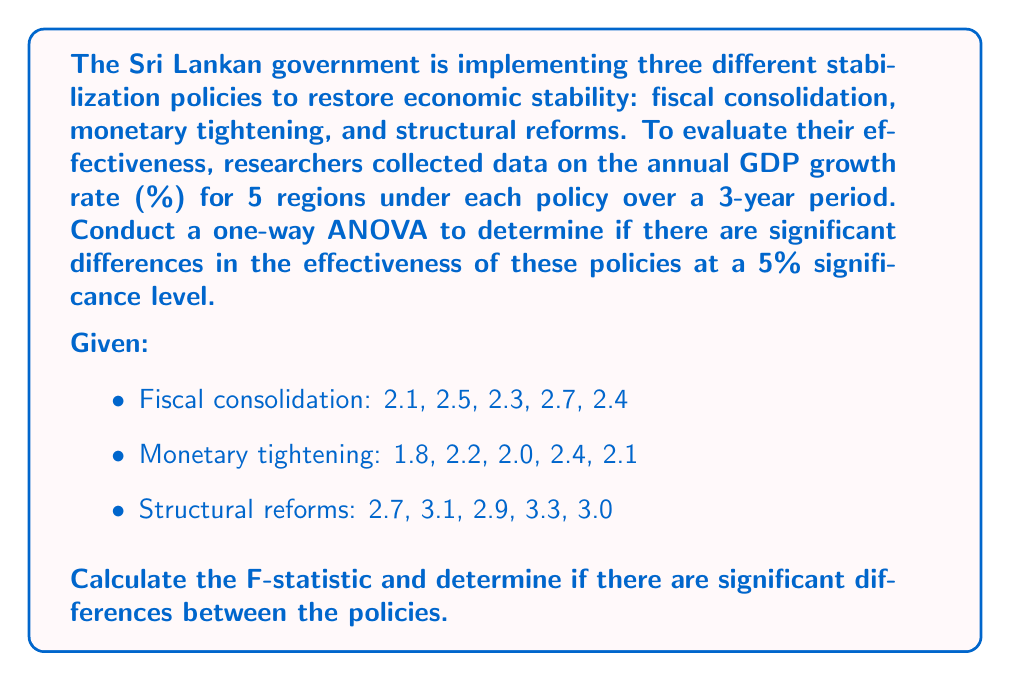Could you help me with this problem? To conduct a one-way ANOVA, we'll follow these steps:

1. Calculate the means for each group:
   Fiscal consolidation: $\bar{x}_1 = \frac{2.1 + 2.5 + 2.3 + 2.7 + 2.4}{5} = 2.4$
   Monetary tightening: $\bar{x}_2 = \frac{1.8 + 2.2 + 2.0 + 2.4 + 2.1}{5} = 2.1$
   Structural reforms: $\bar{x}_3 = \frac{2.7 + 3.1 + 2.9 + 3.3 + 3.0}{5} = 3.0$

2. Calculate the grand mean:
   $\bar{x} = \frac{2.4 + 2.1 + 3.0}{3} = 2.5$

3. Calculate the Sum of Squares Between (SSB):
   $$SSB = \sum_{i=1}^{k} n_i(\bar{x}_i - \bar{x})^2$$
   $$SSB = 5(2.4 - 2.5)^2 + 5(2.1 - 2.5)^2 + 5(3.0 - 2.5)^2 = 2.1$$

4. Calculate the Sum of Squares Within (SSW):
   $$SSW = \sum_{i=1}^{k} \sum_{j=1}^{n_i} (x_{ij} - \bar{x}_i)^2$$
   $$SSW = [(2.1-2.4)^2 + (2.5-2.4)^2 + (2.3-2.4)^2 + (2.7-2.4)^2 + (2.4-2.4)^2] +$$
   $$[(1.8-2.1)^2 + (2.2-2.1)^2 + (2.0-2.1)^2 + (2.4-2.1)^2 + (2.1-2.1)^2] +$$
   $$[(2.7-3.0)^2 + (3.1-3.0)^2 + (2.9-3.0)^2 + (3.3-3.0)^2 + (3.0-3.0)^2]$$
   $$SSW = 0.28 + 0.22 + 0.28 = 0.78$$

5. Calculate degrees of freedom:
   $df_{between} = k - 1 = 3 - 1 = 2$
   $df_{within} = N - k = 15 - 3 = 12$

6. Calculate Mean Square Between (MSB) and Mean Square Within (MSW):
   $$MSB = \frac{SSB}{df_{between}} = \frac{2.1}{2} = 1.05$$
   $$MSW = \frac{SSW}{df_{within}} = \frac{0.78}{12} = 0.065$$

7. Calculate the F-statistic:
   $$F = \frac{MSB}{MSW} = \frac{1.05}{0.065} = 16.15$$

8. Determine the critical F-value:
   For $\alpha = 0.05$, $df_{between} = 2$, and $df_{within} = 12$, the critical F-value is approximately 3.89.

9. Compare the F-statistic to the critical F-value:
   Since $16.15 > 3.89$, we reject the null hypothesis.
Answer: The F-statistic is 16.15, which is greater than the critical F-value of 3.89 at the 5% significance level. Therefore, we reject the null hypothesis and conclude that there are significant differences in the effectiveness of the three stabilization policies. 